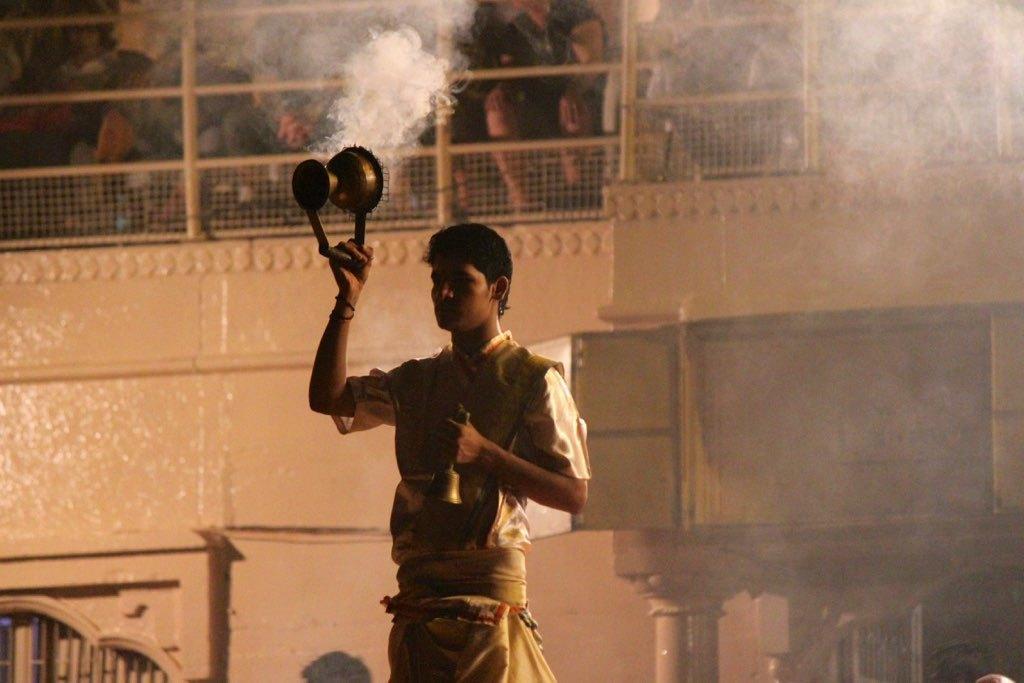Could you give a brief overview of what you see in this image? In this image we can see a person holding an object and a bell and at the background there is a building and some people in the building. 